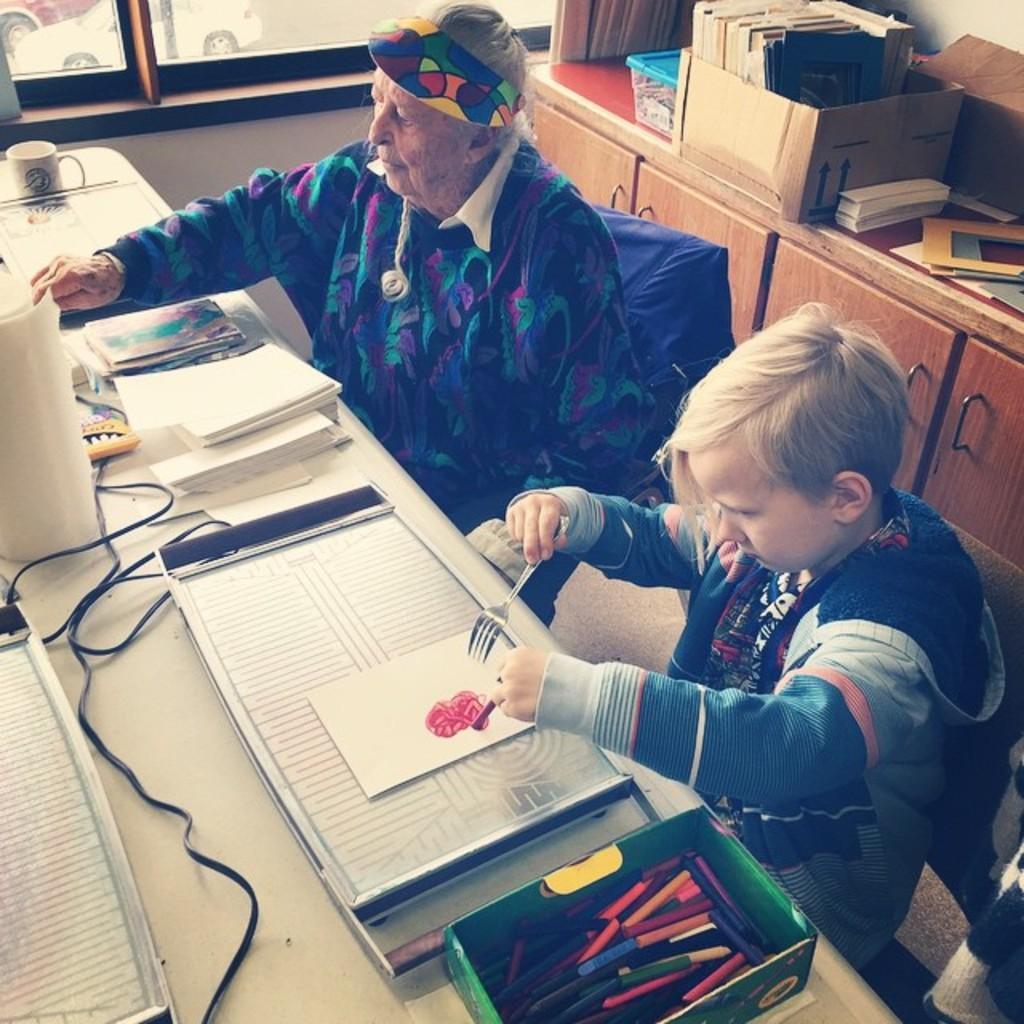How would you summarize this image in a sentence or two? As we can see in the image there is a window, few people sitting on chairs and there is a table. On tables there are boxes, papers, books, wire and cup. 